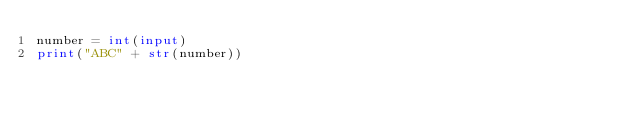<code> <loc_0><loc_0><loc_500><loc_500><_Python_>number = int(input)
print("ABC" + str(number))</code> 